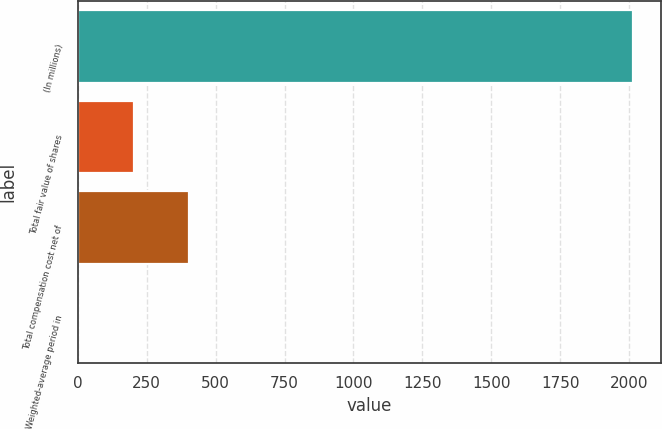Convert chart to OTSL. <chart><loc_0><loc_0><loc_500><loc_500><bar_chart><fcel>(In millions)<fcel>Total fair value of shares<fcel>Total compensation cost net of<fcel>Weighted-average period in<nl><fcel>2015<fcel>203.3<fcel>404.6<fcel>2<nl></chart> 